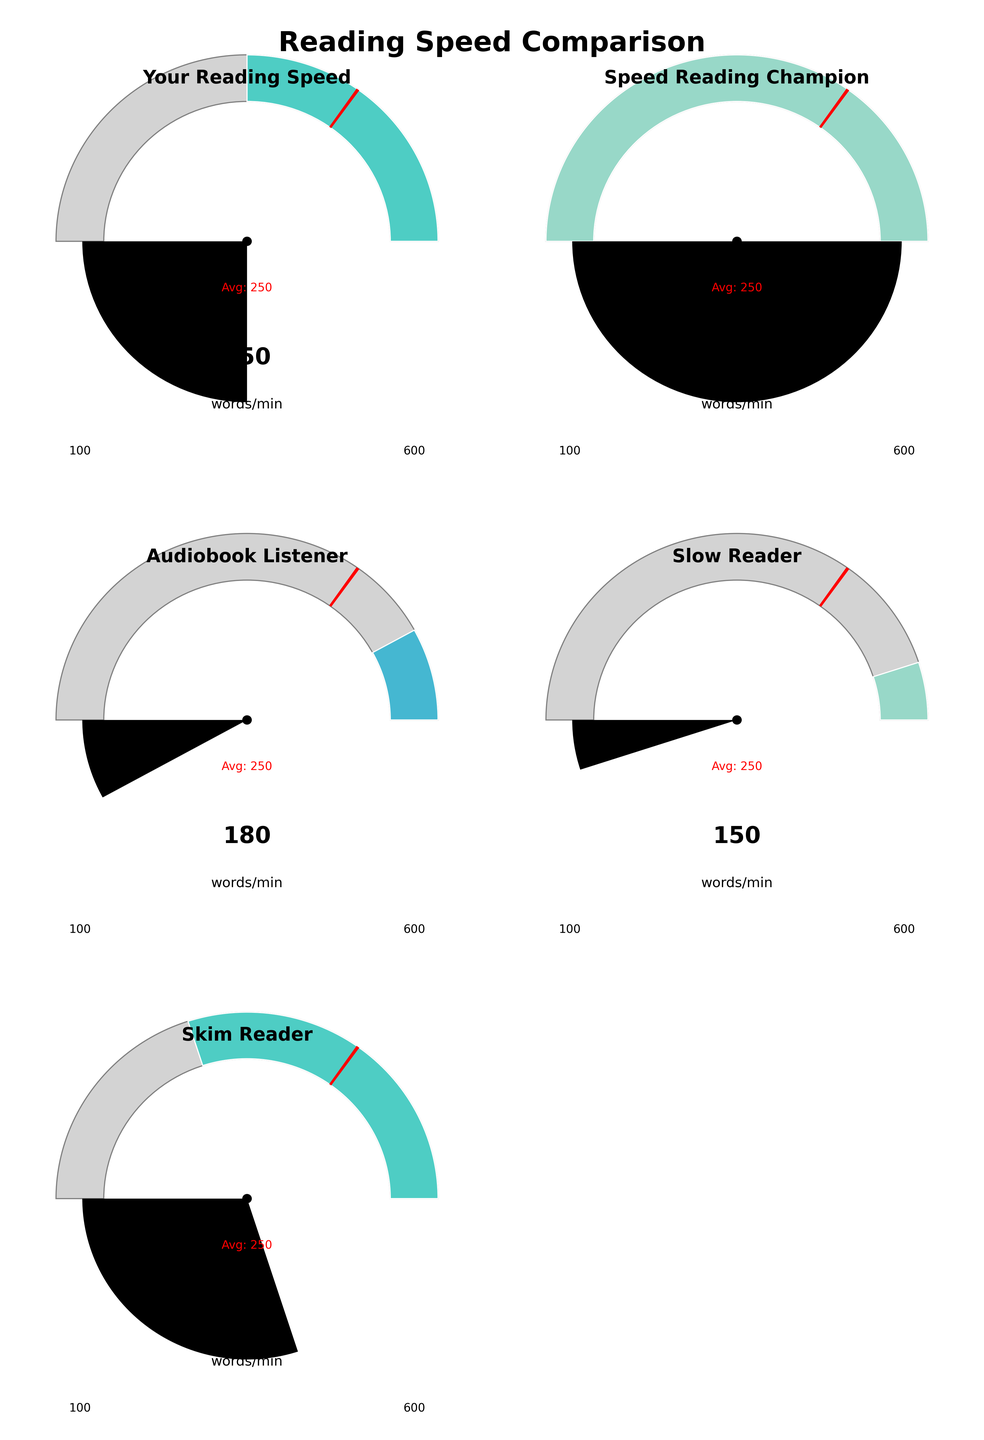What's the title of the figure? The title of the figure is found at the top and it summarizes the entire plot. It states "Reading Speed Comparison," indicating that the figure compares different reading speeds.
Answer: Reading Speed Comparison What are the minimum and maximum values shown on the gauges? Each gauge has two numbers at the bottom corners indicating the range of values. The minimum value is 100 words per minute, and the maximum value is 600 words per minute for all categories.
Answer: 100 and 600 How does "Your Reading Speed" compare to the average reading speed? The gauge for "Your Reading Speed" shows 350 words per minute. The average is marked with a red line at 250 words per minute. Comparing the two, 350 is higher than the average of 250.
Answer: Higher What is the average reading speed marked in the gauges? The average reading speed is indicated by a red line across all gauges, and it is numerically labeled as 250 words per minute.
Answer: 250 Which category has the lowest reading speed? By looking at the values in each gauge, "Slow Reader" has the lowest speed of 150 words per minute.
Answer: Slow Reader Which gauge shows a reading speed of 400 words per minute? The "Skim Reader" category has a reading speed gauge that points to 400 words per minute.
Answer: Skim Reader How many gauges display a reading speed above the average? The average reading speed is 250 words per minute. "Your Reading Speed" (350) and "Skim Reader" (400) are both above the average. Therefore, there are two gauges above the average.
Answer: 2 Rank the categories from fastest to slowest reading speed. To rank from fastest to slowest, we compare the values shown in each gauge: 
1. Speed Reading Champion (600)
2. Skim Reader (400)
3. Your Reading Speed (350)
4. Audiobook Listener (180)
5. Slow Reader (150)
Answer: Speed Reading Champion, Skim Reader, Your Reading Speed, Audiobook Listener, Slow Reader What does the red line indicate on each gauge? The red line on each gauge indicates the average reading speed, which is labeled as 250 words per minute across all gauges.
Answer: Average Is the "Audiobook Listener" speed above or below the average reading speed? The "Audiobook Listener" gauge shows 180 words per minute. Since 180 is less than 250, it is below the average reading speed.
Answer: Below 